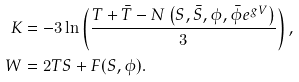<formula> <loc_0><loc_0><loc_500><loc_500>K & = - 3 \ln \left ( \frac { T + \bar { T } - N \left ( S , \bar { S } , \phi , \bar { \phi } e ^ { g V } \right ) } { 3 } \right ) , \\ W & = 2 T S + F ( S , \phi ) .</formula> 